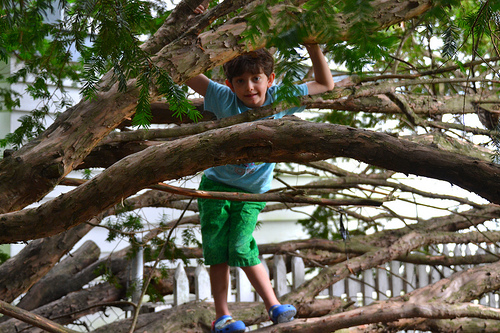<image>
Is the child on the branch? Yes. Looking at the image, I can see the child is positioned on top of the branch, with the branch providing support. 